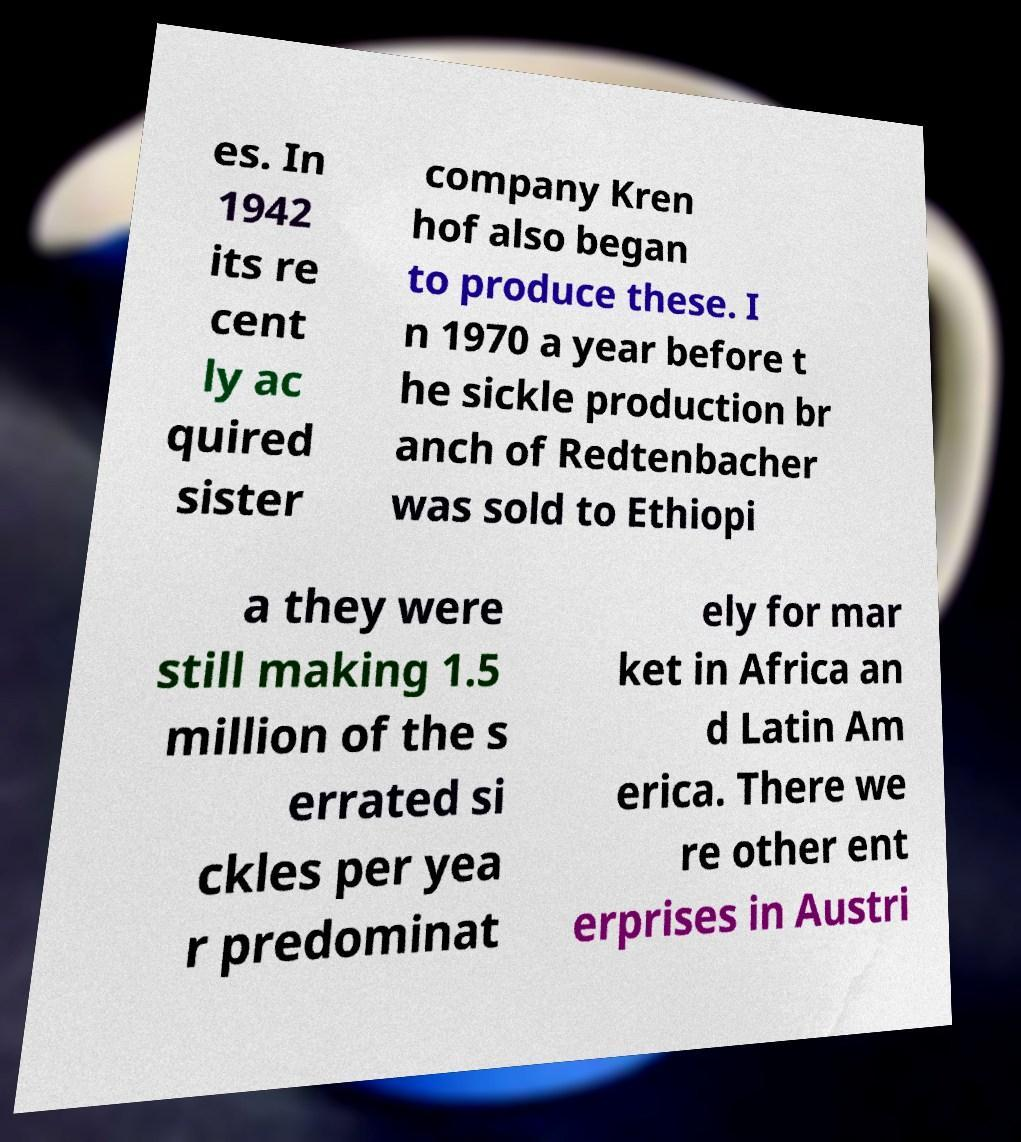Please read and relay the text visible in this image. What does it say? es. In 1942 its re cent ly ac quired sister company Kren hof also began to produce these. I n 1970 a year before t he sickle production br anch of Redtenbacher was sold to Ethiopi a they were still making 1.5 million of the s errated si ckles per yea r predominat ely for mar ket in Africa an d Latin Am erica. There we re other ent erprises in Austri 